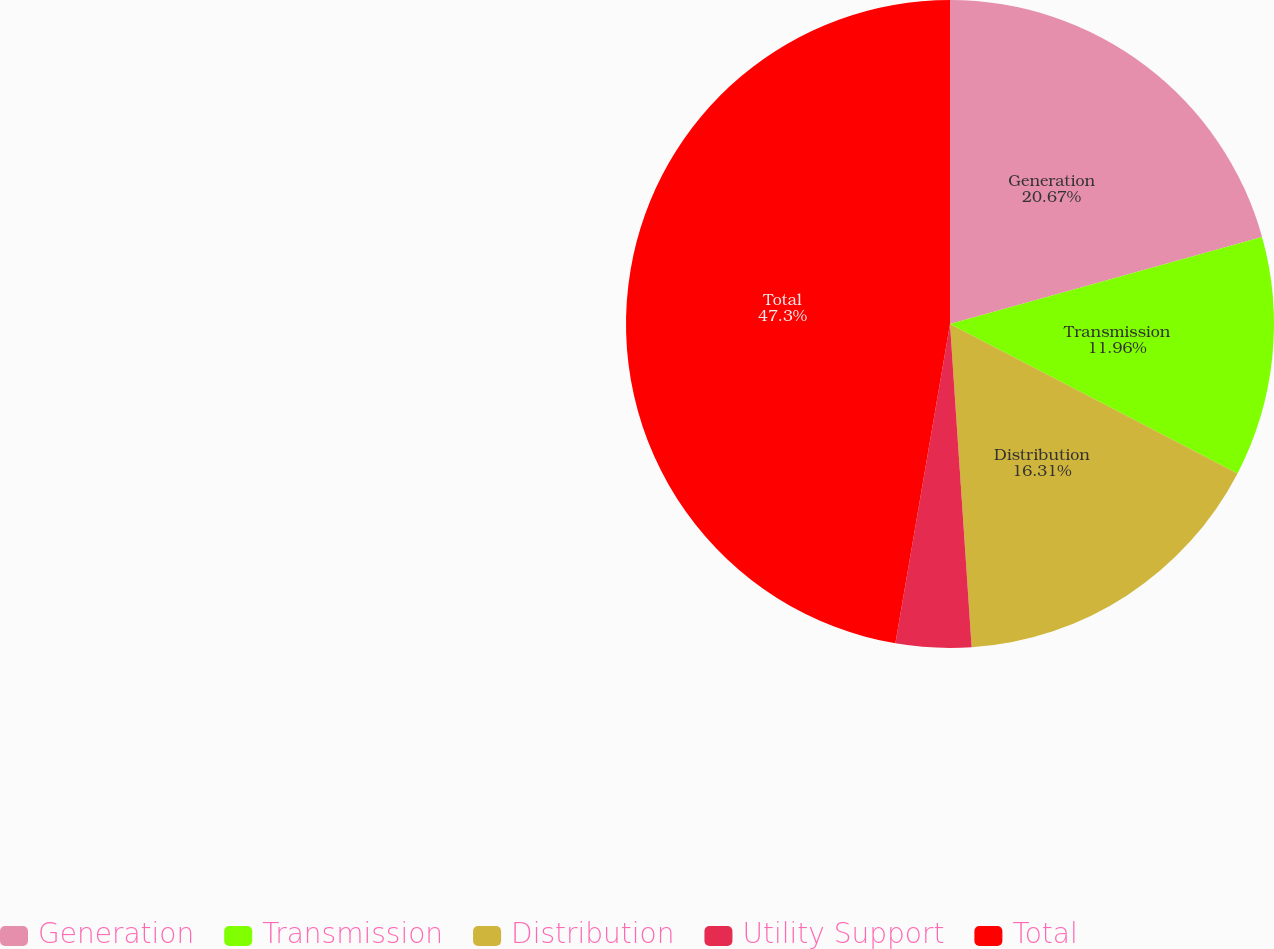<chart> <loc_0><loc_0><loc_500><loc_500><pie_chart><fcel>Generation<fcel>Transmission<fcel>Distribution<fcel>Utility Support<fcel>Total<nl><fcel>20.67%<fcel>11.96%<fcel>16.31%<fcel>3.76%<fcel>47.31%<nl></chart> 